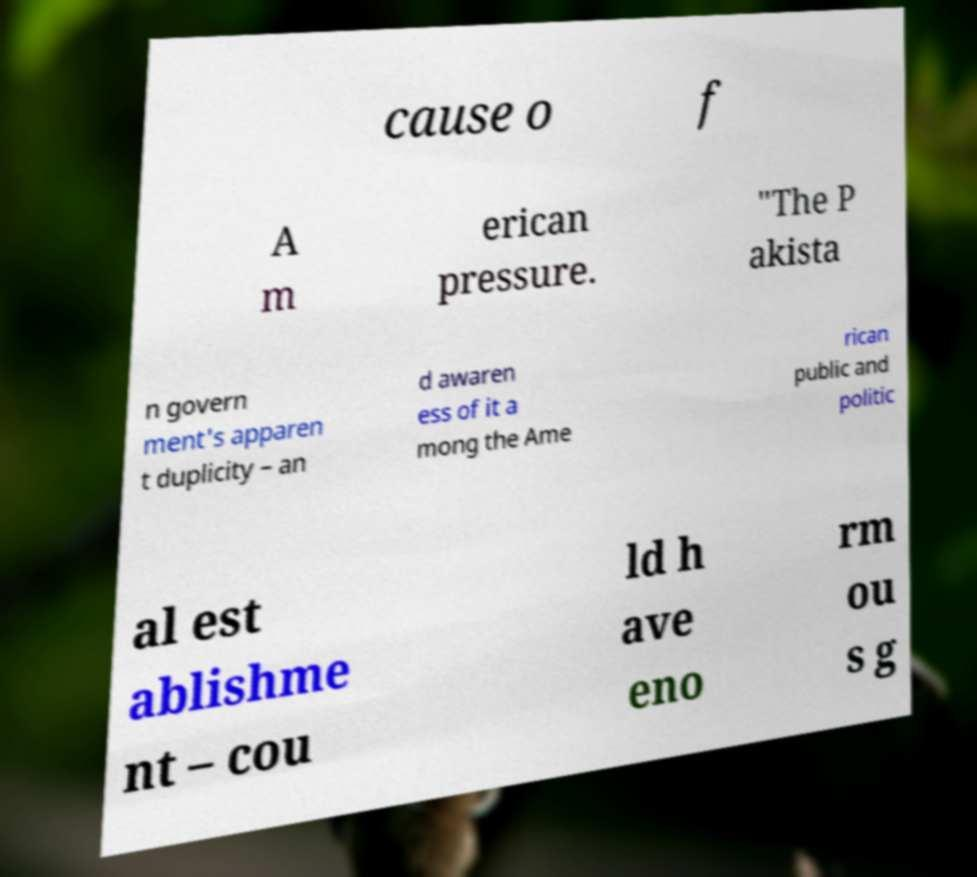For documentation purposes, I need the text within this image transcribed. Could you provide that? cause o f A m erican pressure. "The P akista n govern ment's apparen t duplicity – an d awaren ess of it a mong the Ame rican public and politic al est ablishme nt – cou ld h ave eno rm ou s g 